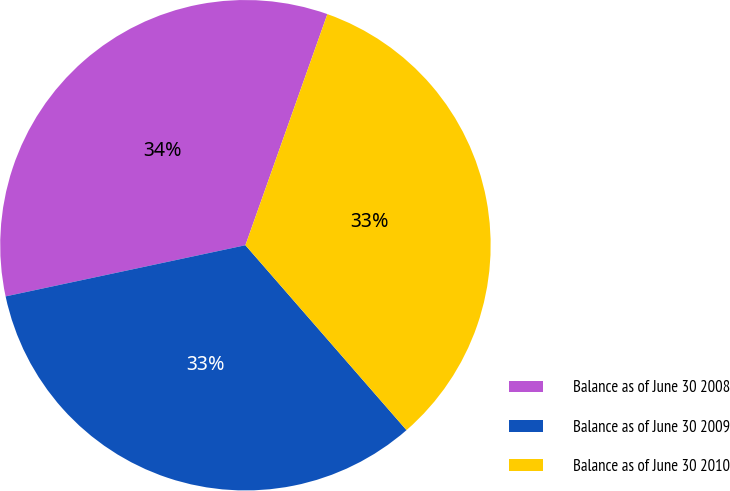Convert chart. <chart><loc_0><loc_0><loc_500><loc_500><pie_chart><fcel>Balance as of June 30 2008<fcel>Balance as of June 30 2009<fcel>Balance as of June 30 2010<nl><fcel>33.77%<fcel>33.06%<fcel>33.17%<nl></chart> 